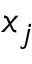<formula> <loc_0><loc_0><loc_500><loc_500>x _ { j }</formula> 